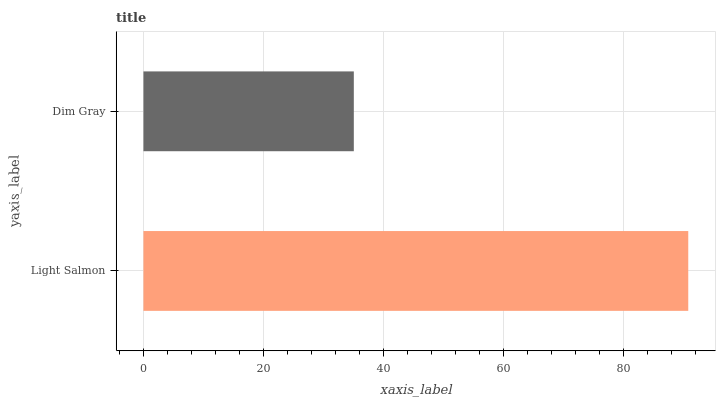Is Dim Gray the minimum?
Answer yes or no. Yes. Is Light Salmon the maximum?
Answer yes or no. Yes. Is Dim Gray the maximum?
Answer yes or no. No. Is Light Salmon greater than Dim Gray?
Answer yes or no. Yes. Is Dim Gray less than Light Salmon?
Answer yes or no. Yes. Is Dim Gray greater than Light Salmon?
Answer yes or no. No. Is Light Salmon less than Dim Gray?
Answer yes or no. No. Is Light Salmon the high median?
Answer yes or no. Yes. Is Dim Gray the low median?
Answer yes or no. Yes. Is Dim Gray the high median?
Answer yes or no. No. Is Light Salmon the low median?
Answer yes or no. No. 